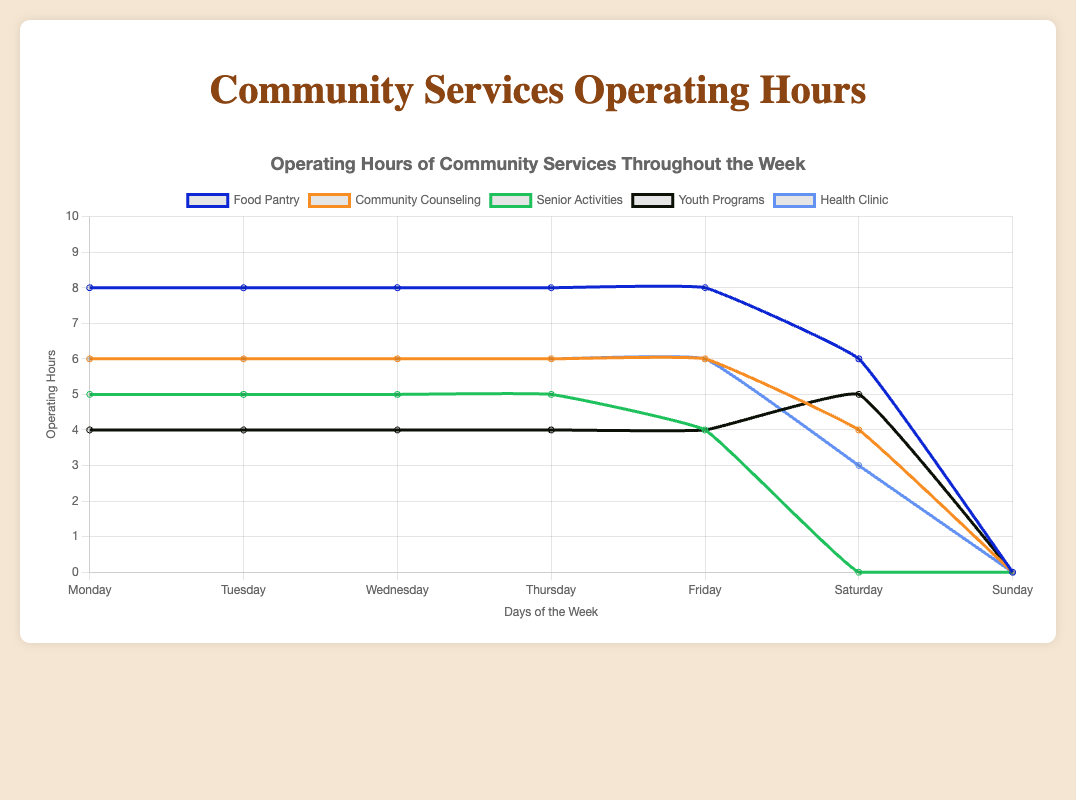What day has the most operating hours for Youth Programs? By looking at the line representing Youth Programs, we see the highest point on Saturday, meaning it has the most operating hours.
Answer: Saturday Which service operates the most on Mondays? By looking vertically at the 'Monday' segment, we see the line for 'Food Pantry' is the highest, indicating it operates the most hours.
Answer: Food Pantry Are there any services that do not operate on Sundays? The lines for all services drop to '0' on Sundays, indicating none of them operate on that day.
Answer: All services What is the total number of operating hours for the Health Clinic throughout the week? Add the operating hours for each day: 6 + 6 + 6 + 6 + 6 + 3 + 0.
Answer: 33 Which days does the Food Pantry operate fewer hours compared to Community Counseling? Food Pantry and Community Counseling have the same hours from Monday to Friday, but Food Pantry has 6 hours on Saturday while Community Counseling has 4. So, Food Pantry doesn't operate fewer hours on any day.
Answer: None On which day do Senior Activities operate fewer hours compared to Youth Programs? Senior Activities operate fewer hours on Saturday compared to Youth Programs, which is 0 vs 5 hours.
Answer: Saturday What is the average operating hours for the Food Pantry from Monday to Saturday? Sum the hours (8+8+8+8+8+6) to get 46, then divide by 6.
Answer: 7.67 Which day of the week does the Food Pantry have the same operating hours as the Health Clinic? Both the Food Pantry and the Health Clinic have the same operating hours from Monday to Friday (8 hours vs 6 hours not the same, and on Saturday 6 vs 3 not the same).
Answer: None What is the difference in operating hours between the Senior Activities on Friday and Saturday? The operating hours are 4 on Friday and 0 on Saturday. 4 - 0 = 4.
Answer: 4 